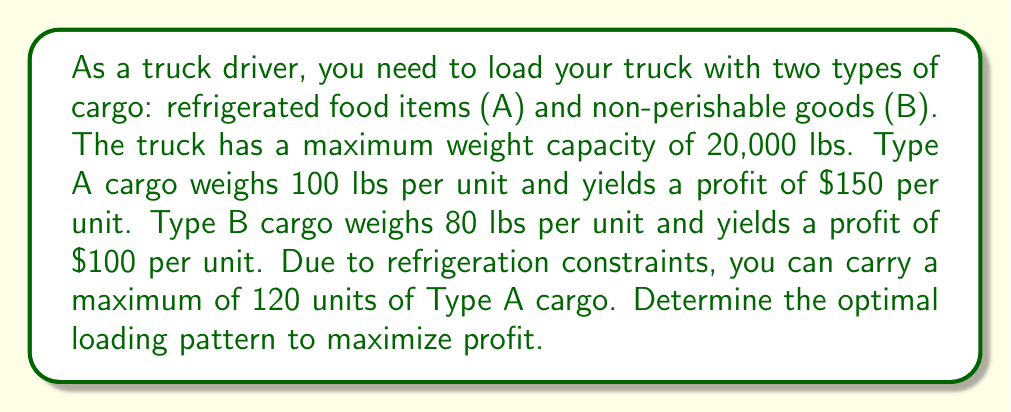Could you help me with this problem? This problem can be solved using linear programming. Let's define our variables:

$x$ = number of units of Type A cargo
$y$ = number of units of Type B cargo

Our objective function (profit) is:
$$P = 150x + 100y$$

Subject to the following constraints:
1. Weight constraint: $100x + 80y \leq 20000$
2. Refrigeration constraint: $x \leq 120$
3. Non-negativity: $x \geq 0, y \geq 0$

To solve this, we can use the graphical method:

1. Plot the constraints:
   [asy]
   import geometry;
   
   size(200);
   
   xaxis("x", 0, 250, Arrow);
   yaxis("y", 0, 250, Arrow);
   
   draw((0,250)--(200,0), blue);
   draw((120,0)--(120,250), red);
   
   label("100x + 80y = 20000", (180,30), blue);
   label("x = 120", (130,200), red);
   
   fill((0,0)--(120,0)--(120,100)--(100,150)--(0,250)--cycle, lightgreen+opacity(0.2));
   
   dot((120,100), red);
   label("(120, 100)", (130,100), E);
   
   dot((100,150), red);
   label("(100, 150)", (110,150), E);
   [/asy]

2. The feasible region is the shaded area.
3. The optimal solution will be at one of the corner points of the feasible region.
4. The corner points are (0,0), (120,0), (120,100), and (100,150).
5. Evaluate the profit function at each point:
   P(0,0) = $0
   P(120,0) = $18,000
   P(120,100) = $28,000
   P(100,150) = $30,000

The maximum profit occurs at the point (100,150).
Answer: The optimal loading pattern is 100 units of Type A cargo and 150 units of Type B cargo, yielding a maximum profit of $30,000. 